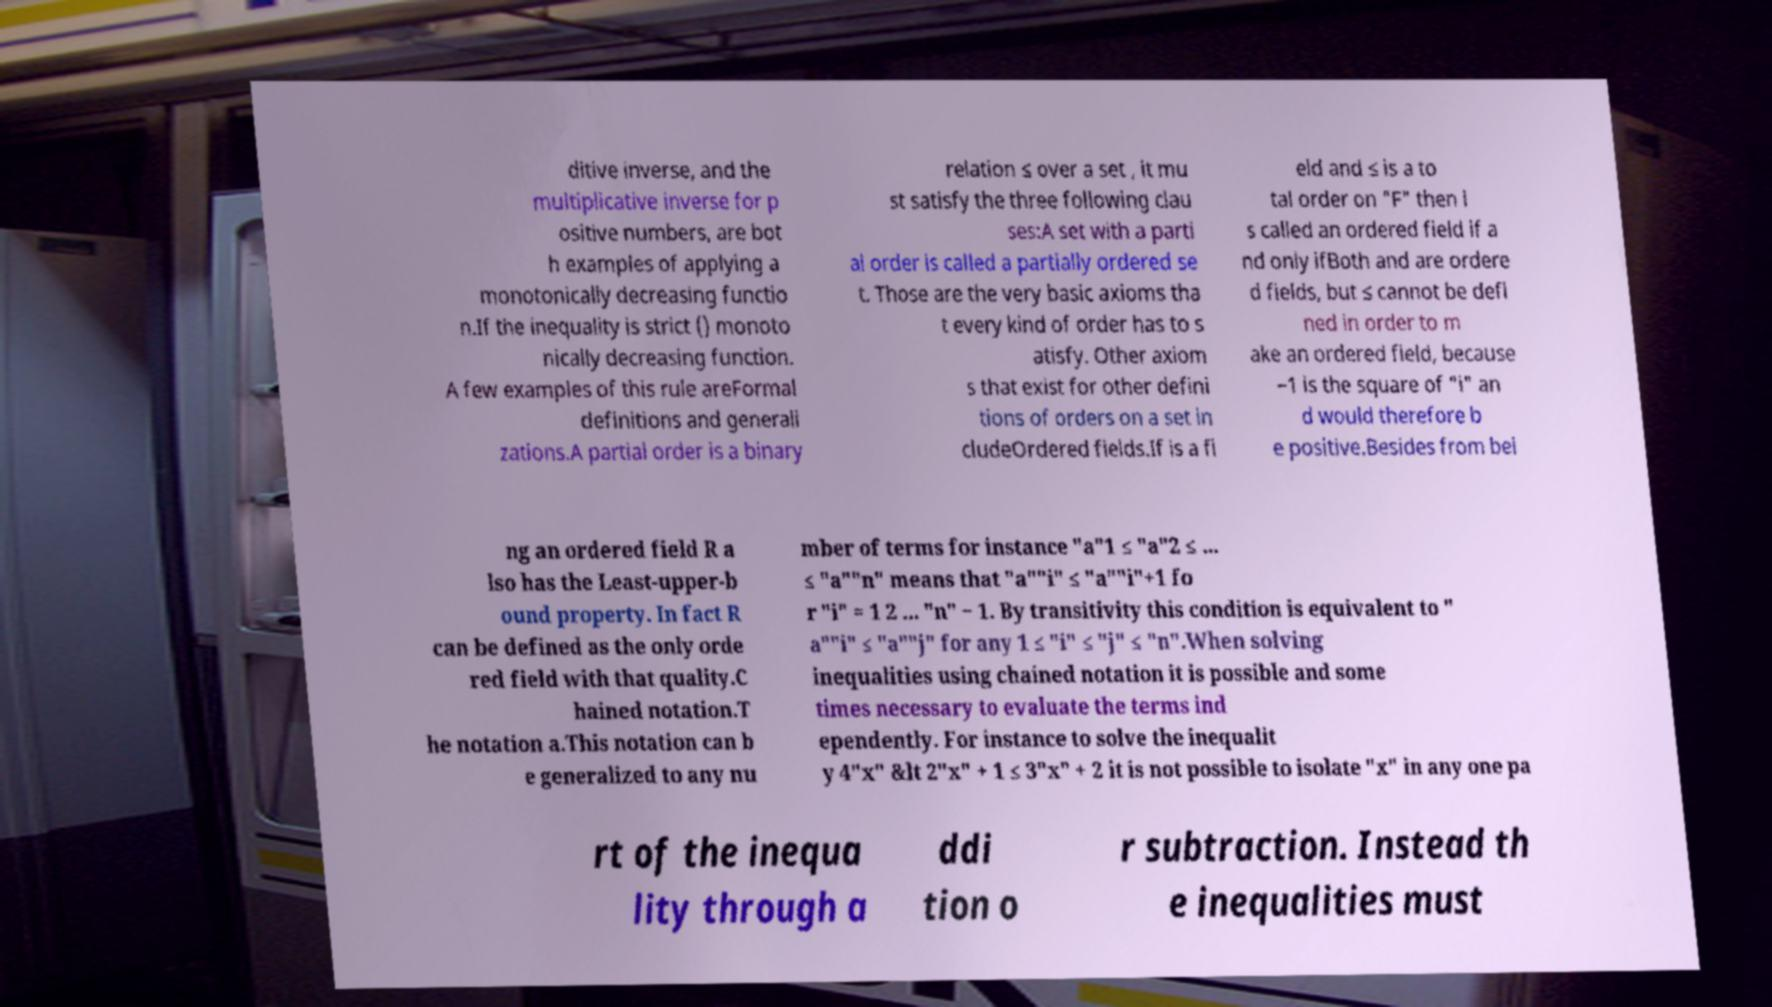For documentation purposes, I need the text within this image transcribed. Could you provide that? ditive inverse, and the multiplicative inverse for p ositive numbers, are bot h examples of applying a monotonically decreasing functio n.If the inequality is strict () monoto nically decreasing function. A few examples of this rule areFormal definitions and generali zations.A partial order is a binary relation ≤ over a set , it mu st satisfy the three following clau ses:A set with a parti al order is called a partially ordered se t. Those are the very basic axioms tha t every kind of order has to s atisfy. Other axiom s that exist for other defini tions of orders on a set in cludeOrdered fields.If is a fi eld and ≤ is a to tal order on "F" then i s called an ordered field if a nd only ifBoth and are ordere d fields, but ≤ cannot be defi ned in order to m ake an ordered field, because −1 is the square of "i" an d would therefore b e positive.Besides from bei ng an ordered field R a lso has the Least-upper-b ound property. In fact R can be defined as the only orde red field with that quality.C hained notation.T he notation a.This notation can b e generalized to any nu mber of terms for instance "a"1 ≤ "a"2 ≤ ... ≤ "a""n" means that "a""i" ≤ "a""i"+1 fo r "i" = 1 2 ... "n" − 1. By transitivity this condition is equivalent to " a""i" ≤ "a""j" for any 1 ≤ "i" ≤ "j" ≤ "n".When solving inequalities using chained notation it is possible and some times necessary to evaluate the terms ind ependently. For instance to solve the inequalit y 4"x" &lt 2"x" + 1 ≤ 3"x" + 2 it is not possible to isolate "x" in any one pa rt of the inequa lity through a ddi tion o r subtraction. Instead th e inequalities must 